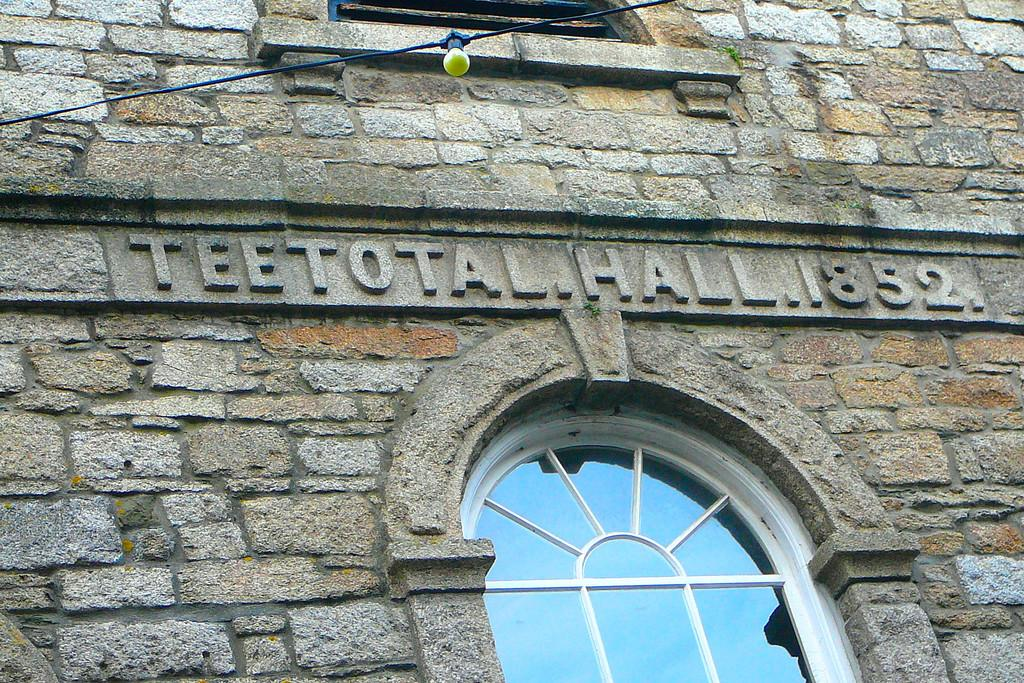What is present on the wall in the image? The wall has some text craft on it. Are there any openings in the wall? Yes, there are windows on the wall. What can be seen in the image related to lighting? There is a light in the image. Is there anything associated with the light? Yes, there is an object is associated with the light. What team is competing in the cemetery in the image? There is no team or competition present in the image; it features a wall with text craft, windows, a light, and an associated object. 